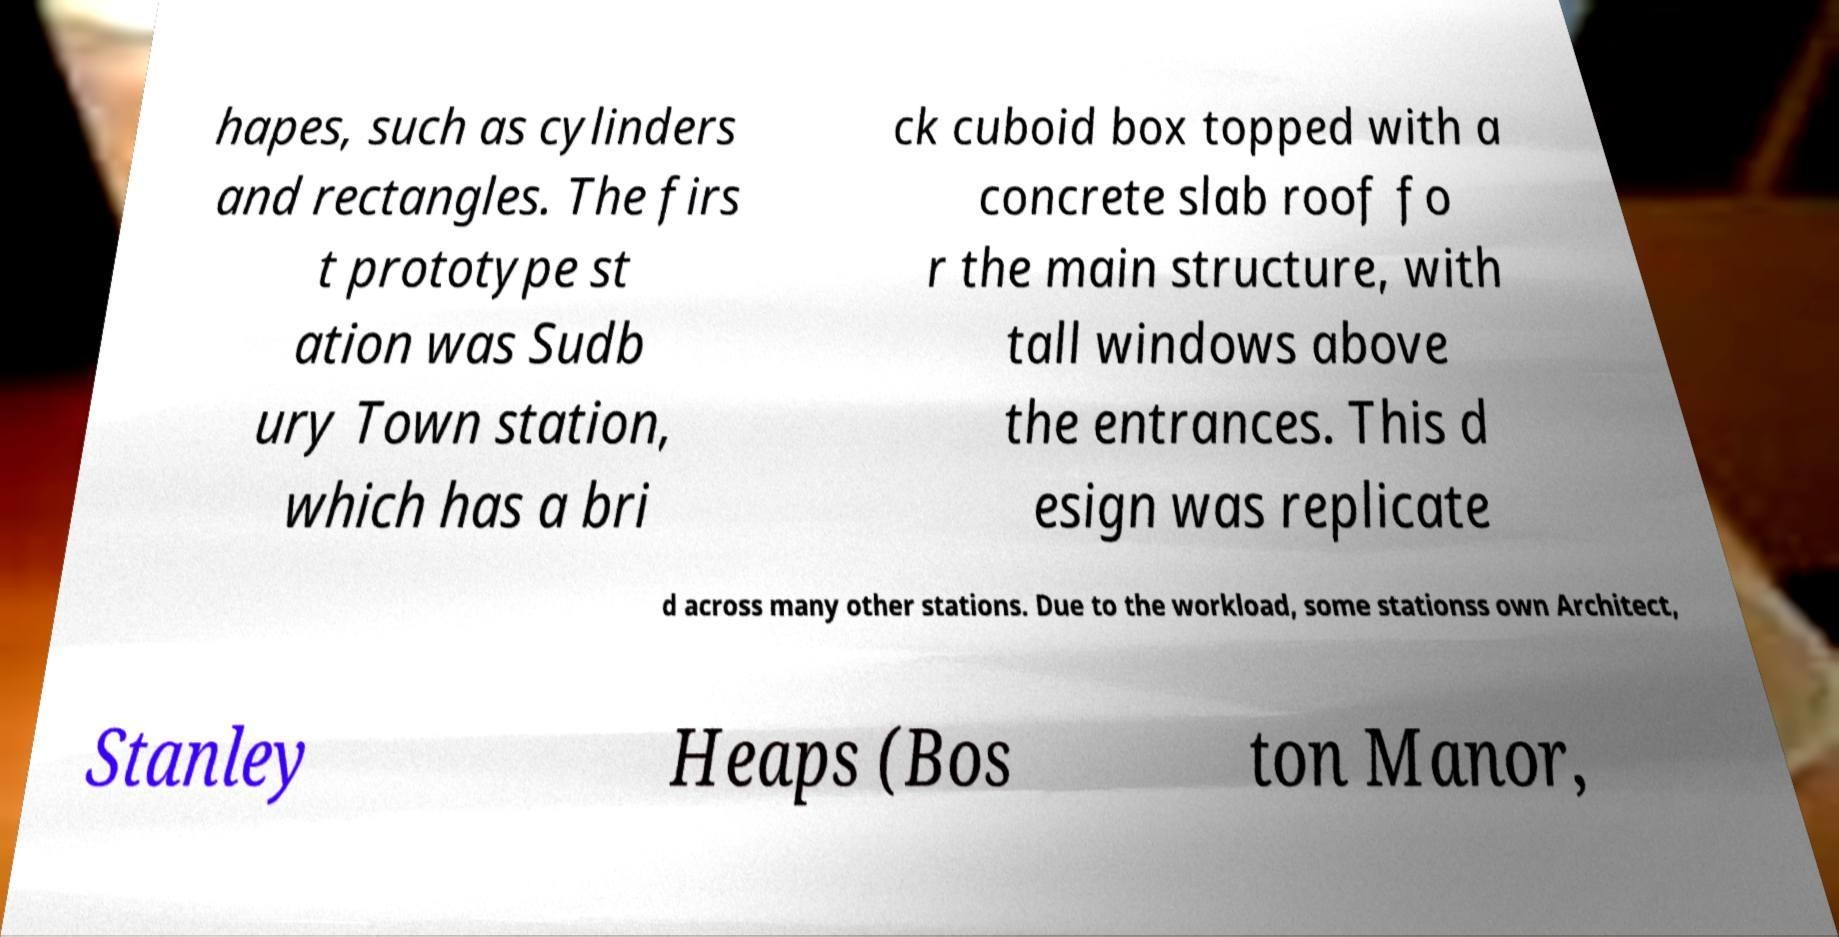Can you read and provide the text displayed in the image?This photo seems to have some interesting text. Can you extract and type it out for me? hapes, such as cylinders and rectangles. The firs t prototype st ation was Sudb ury Town station, which has a bri ck cuboid box topped with a concrete slab roof fo r the main structure, with tall windows above the entrances. This d esign was replicate d across many other stations. Due to the workload, some stationss own Architect, Stanley Heaps (Bos ton Manor, 